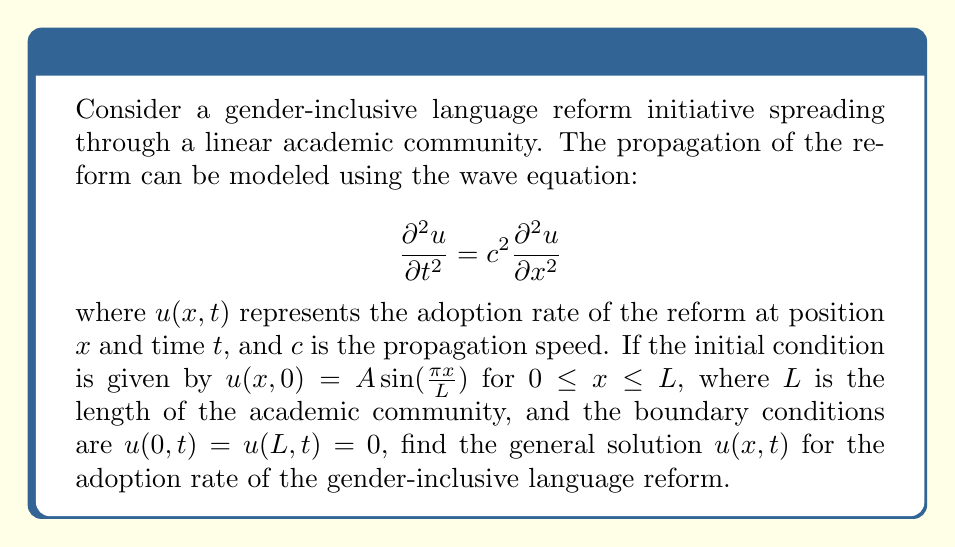Provide a solution to this math problem. To solve this wave equation problem, we'll follow these steps:

1) The general solution for the wave equation with the given boundary conditions is of the form:

   $$u(x,t) = \sum_{n=1}^{\infty} (A_n \cos(\omega_n t) + B_n \sin(\omega_n t)) \sin(\frac{n\pi x}{L})$$

   where $\omega_n = \frac{n\pi c}{L}$

2) Given the initial condition $u(x,0) = A \sin(\frac{\pi x}{L})$, we can see that only the first term (n=1) in the series is non-zero, and it matches the spatial part of our initial condition.

3) Therefore, our solution simplifies to:

   $$u(x,t) = (A_1 \cos(\omega_1 t) + B_1 \sin(\omega_1 t)) \sin(\frac{\pi x}{L})$$

4) To determine $A_1$ and $B_1$, we use the initial conditions:

   At $t=0$: $u(x,0) = A \sin(\frac{\pi x}{L}) = A_1 \sin(\frac{\pi x}{L})$
   
   Therefore, $A_1 = A$

5) For $B_1$, we need to use the initial velocity condition. However, it's not given in the problem. In the absence of this information, we can assume the initial velocity is zero, which means $B_1 = 0$.

6) Substituting these values and $\omega_1 = \frac{\pi c}{L}$, we get the final solution:

   $$u(x,t) = A \cos(\frac{\pi c t}{L}) \sin(\frac{\pi x}{L})$$

This solution represents a standing wave, where the spatial distribution of the adoption rate oscillates in place over time.
Answer: $$u(x,t) = A \cos(\frac{\pi c t}{L}) \sin(\frac{\pi x}{L})$$ 